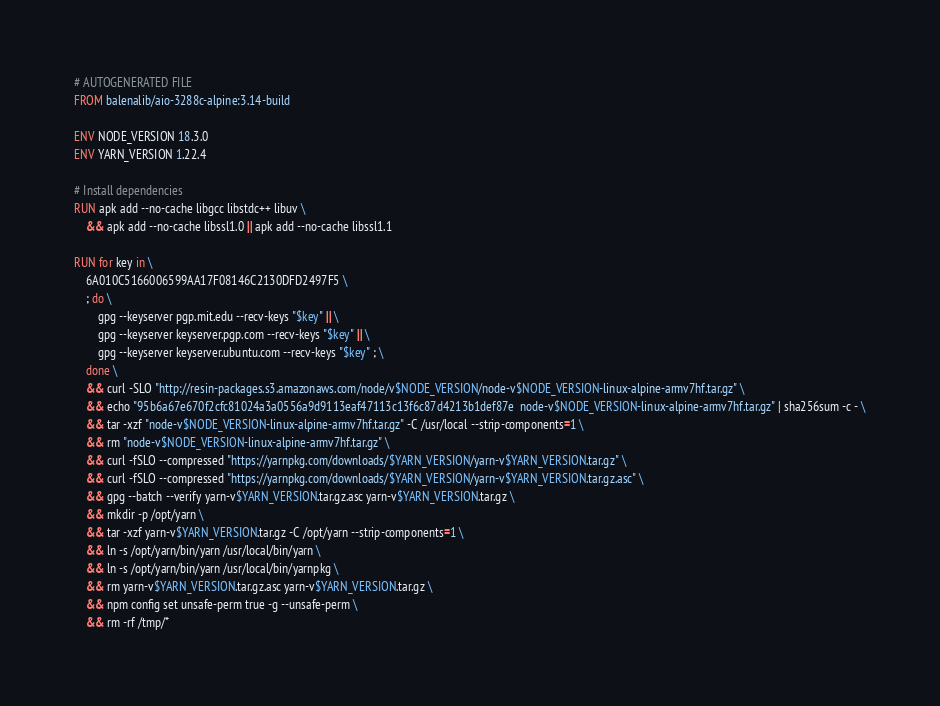<code> <loc_0><loc_0><loc_500><loc_500><_Dockerfile_># AUTOGENERATED FILE
FROM balenalib/aio-3288c-alpine:3.14-build

ENV NODE_VERSION 18.3.0
ENV YARN_VERSION 1.22.4

# Install dependencies
RUN apk add --no-cache libgcc libstdc++ libuv \
	&& apk add --no-cache libssl1.0 || apk add --no-cache libssl1.1

RUN for key in \
	6A010C5166006599AA17F08146C2130DFD2497F5 \
	; do \
		gpg --keyserver pgp.mit.edu --recv-keys "$key" || \
		gpg --keyserver keyserver.pgp.com --recv-keys "$key" || \
		gpg --keyserver keyserver.ubuntu.com --recv-keys "$key" ; \
	done \
	&& curl -SLO "http://resin-packages.s3.amazonaws.com/node/v$NODE_VERSION/node-v$NODE_VERSION-linux-alpine-armv7hf.tar.gz" \
	&& echo "95b6a67e670f2cfc81024a3a0556a9d9113eaf47113c13f6c87d4213b1def87e  node-v$NODE_VERSION-linux-alpine-armv7hf.tar.gz" | sha256sum -c - \
	&& tar -xzf "node-v$NODE_VERSION-linux-alpine-armv7hf.tar.gz" -C /usr/local --strip-components=1 \
	&& rm "node-v$NODE_VERSION-linux-alpine-armv7hf.tar.gz" \
	&& curl -fSLO --compressed "https://yarnpkg.com/downloads/$YARN_VERSION/yarn-v$YARN_VERSION.tar.gz" \
	&& curl -fSLO --compressed "https://yarnpkg.com/downloads/$YARN_VERSION/yarn-v$YARN_VERSION.tar.gz.asc" \
	&& gpg --batch --verify yarn-v$YARN_VERSION.tar.gz.asc yarn-v$YARN_VERSION.tar.gz \
	&& mkdir -p /opt/yarn \
	&& tar -xzf yarn-v$YARN_VERSION.tar.gz -C /opt/yarn --strip-components=1 \
	&& ln -s /opt/yarn/bin/yarn /usr/local/bin/yarn \
	&& ln -s /opt/yarn/bin/yarn /usr/local/bin/yarnpkg \
	&& rm yarn-v$YARN_VERSION.tar.gz.asc yarn-v$YARN_VERSION.tar.gz \
	&& npm config set unsafe-perm true -g --unsafe-perm \
	&& rm -rf /tmp/*
</code> 